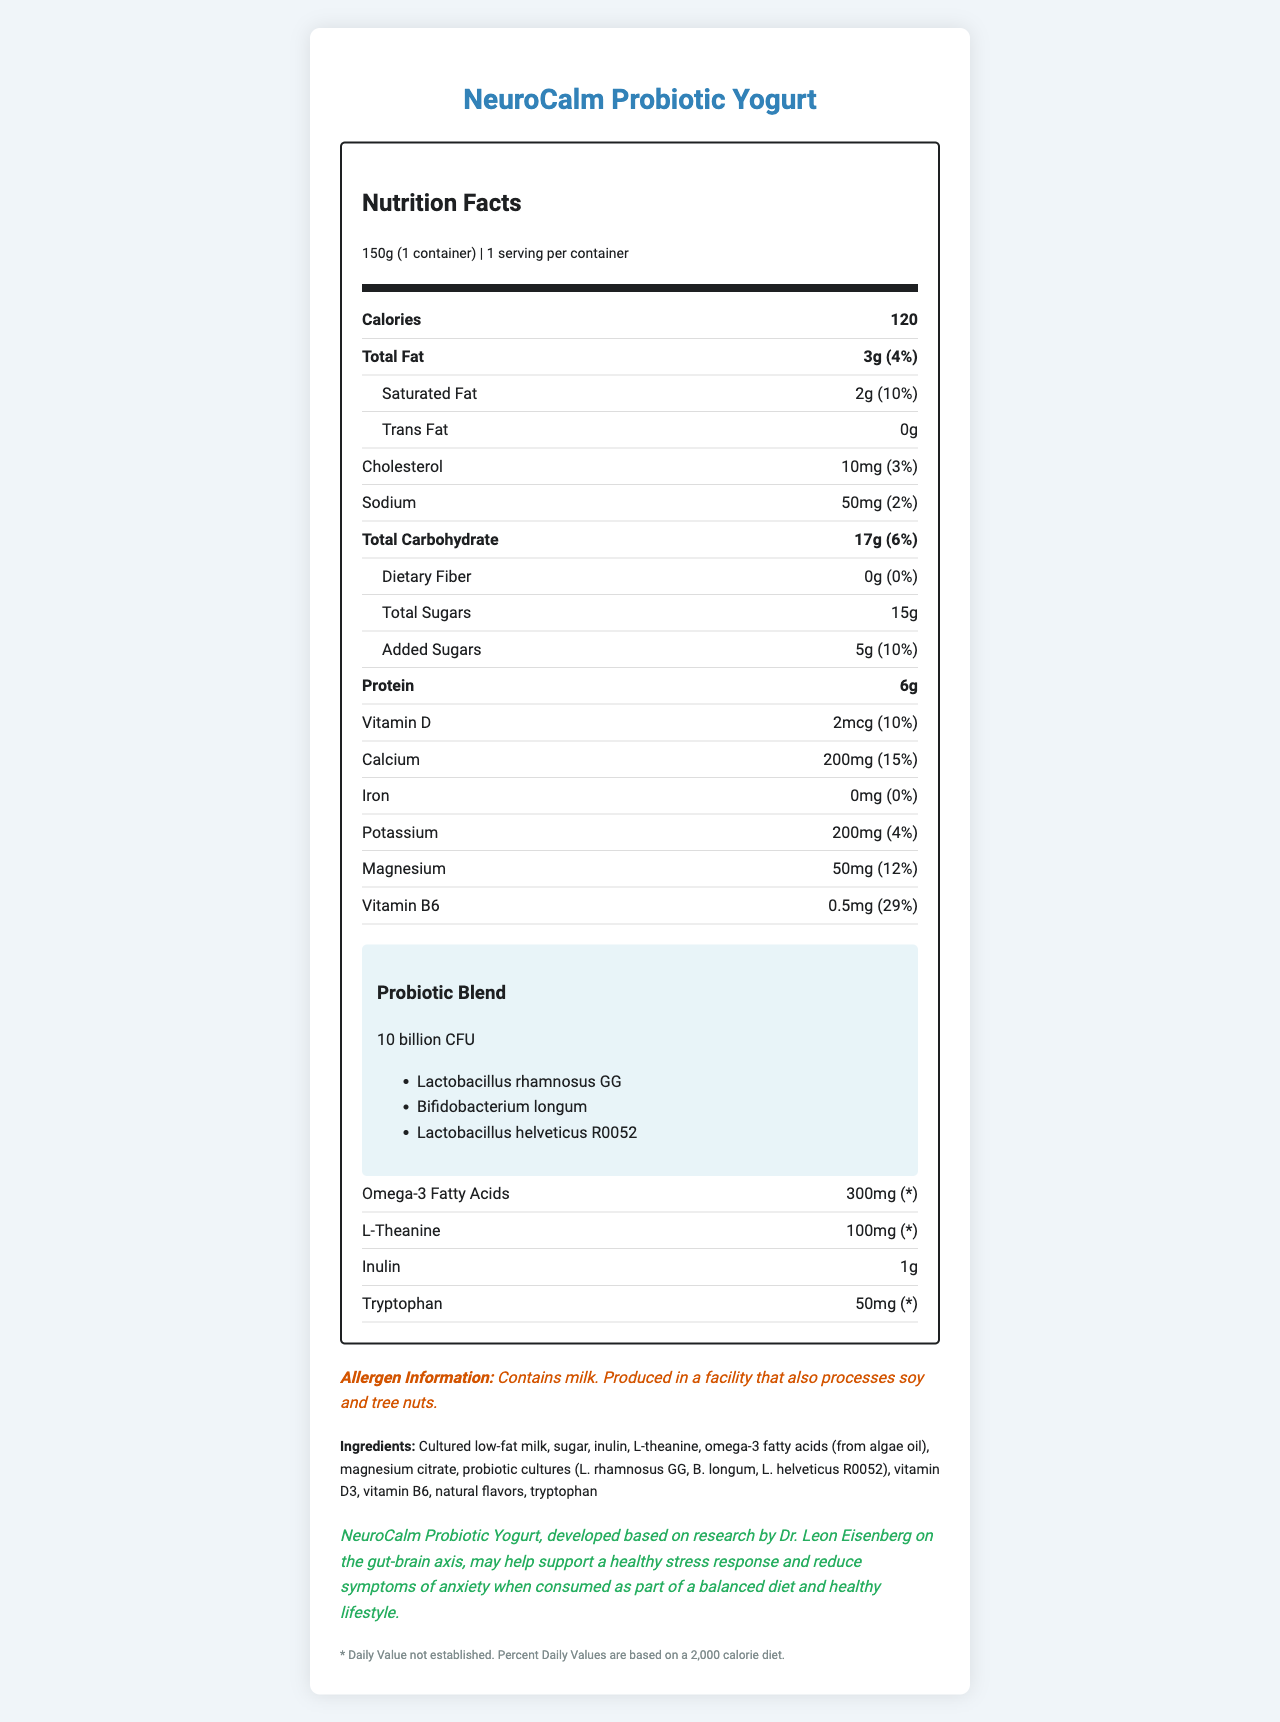What is the serving size of NeuroCalm Probiotic Yogurt? The serving size is explicitly stated as 150g, which is equivalent to 1 container.
Answer: 150g (1 container) How many calories does one serving of NeuroCalm Probiotic Yogurt contain? The document states that each serving (one container) of the yogurt contains 120 calories.
Answer: 120 calories Which probiotic strains are included in NeuroCalm Probiotic Yogurt? The probiotic blend section lists these three specific strains.
Answer: Lactobacillus rhamnosus GG, Bifidobacterium longum, Lactobacillus helveticus R0052 What is the amount of protein per serving in NeuroCalm Probiotic Yogurt? The nutrition label indicates that one serving contains 6g of protein.
Answer: 6g What are the total sugars and added sugars content in NeuroCalm Probiotic Yogurt? The document shows 15g of total sugars and 5g of added sugars per serving.
Answer: Total Sugars: 15g, Added Sugars: 5g Which vitamin is present in the highest percentage of daily value in NeuroCalm Probiotic Yogurt? A. Vitamin D B. Calcium C. Magnesium D. Vitamin B6 Vitamin B6 is present at 29% of the daily value, which is higher than others listed.
Answer: D. Vitamin B6 How much inulin does a serving of NeuroCalm Probiotic Yogurt contain? A. 0g B. 0.5g C. 1g D. 2g The document states that each serving contains 1g of inulin.
Answer: C. 1g Does NeuroCalm Probiotic Yogurt contain any magnesium? The nutrition label lists magnesium with an amount of 50mg per serving.
Answer: Yes Does NeuroCalm Probiotic Yogurt contain any iron? The label indicates 0mg of iron in the yogurt.
Answer: No Does NeuroCalm Probiotic Yogurt contain any trans fat? The document states explicitly that the yogurt contains 0g of trans fat.
Answer: No Summarize the main health claim made about NeuroCalm Probiotic Yogurt. The health claim summary captures the main point that the yogurt supports a healthy stress response and reduces anxiety symptoms, attributing this to the gut-brain axis research by Dr. Eisenberg.
Answer: NeuroCalm Probiotic Yogurt may help support a healthy stress response and reduce symptoms of anxiety when consumed as part of a balanced diet and healthy lifestyle, based on research by Dr. Leon Eisenberg on the gut-brain axis. Can consuming NeuroCalm Probiotic Yogurt alone effectively treat anxiety disorders? The health claim states that the yogurt may help support a healthy stress response and reduce symptoms of anxiety when consumed as part of a balanced diet and healthy lifestyle, implying it should not be used alone to treat anxiety disorders.
Answer: Not enough information 